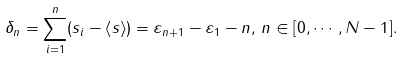Convert formula to latex. <formula><loc_0><loc_0><loc_500><loc_500>\delta _ { n } = \sum _ { i = 1 } ^ { n } ( s _ { i } - \left < s \right > ) = \varepsilon _ { n + 1 } - \varepsilon _ { 1 } - n , \, n \in [ 0 , \cdots , N - 1 ] . \\</formula> 